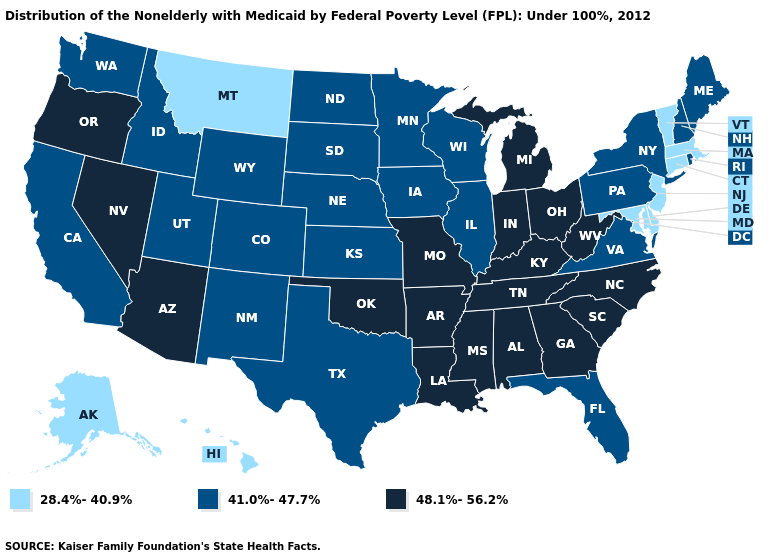Among the states that border Texas , which have the highest value?
Be succinct. Arkansas, Louisiana, Oklahoma. Among the states that border Missouri , does Kansas have the lowest value?
Write a very short answer. Yes. What is the highest value in the USA?
Give a very brief answer. 48.1%-56.2%. Does Maryland have the lowest value in the South?
Give a very brief answer. Yes. What is the value of Indiana?
Be succinct. 48.1%-56.2%. Name the states that have a value in the range 28.4%-40.9%?
Quick response, please. Alaska, Connecticut, Delaware, Hawaii, Maryland, Massachusetts, Montana, New Jersey, Vermont. Does Alaska have the lowest value in the West?
Concise answer only. Yes. Which states have the lowest value in the Northeast?
Keep it brief. Connecticut, Massachusetts, New Jersey, Vermont. What is the value of New Mexico?
Give a very brief answer. 41.0%-47.7%. Does Florida have the lowest value in the USA?
Answer briefly. No. What is the value of Hawaii?
Short answer required. 28.4%-40.9%. Which states hav the highest value in the Northeast?
Be succinct. Maine, New Hampshire, New York, Pennsylvania, Rhode Island. Name the states that have a value in the range 48.1%-56.2%?
Be succinct. Alabama, Arizona, Arkansas, Georgia, Indiana, Kentucky, Louisiana, Michigan, Mississippi, Missouri, Nevada, North Carolina, Ohio, Oklahoma, Oregon, South Carolina, Tennessee, West Virginia. What is the value of Oregon?
Answer briefly. 48.1%-56.2%. 